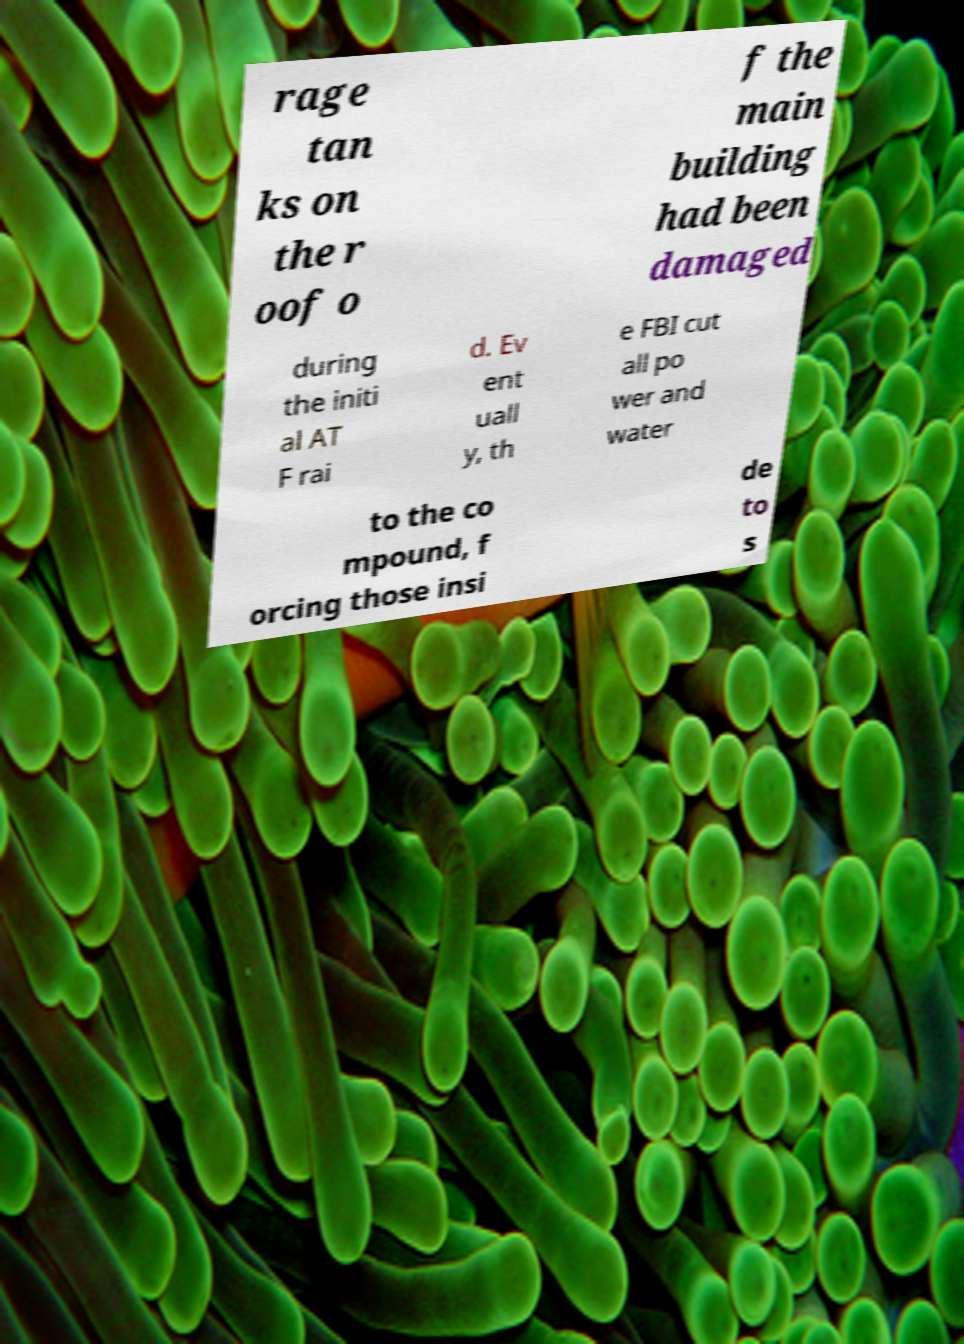For documentation purposes, I need the text within this image transcribed. Could you provide that? rage tan ks on the r oof o f the main building had been damaged during the initi al AT F rai d. Ev ent uall y, th e FBI cut all po wer and water to the co mpound, f orcing those insi de to s 